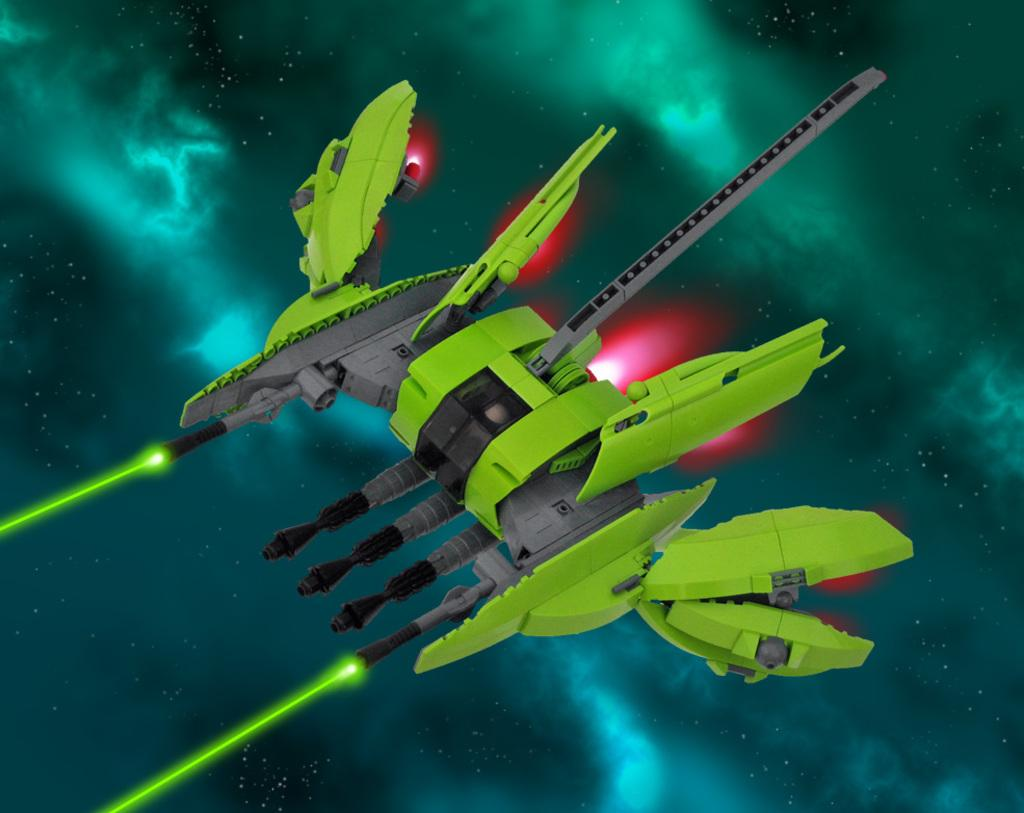What is the main subject in the sky in the image? There is a rocket in the sky in the image. What can be observed around the rocket? Colorful lights are visible around the rocket. Can you tell if the image has been altered or edited? Yes, the image appears to be edited. How many kittens are playing with the engine of the rocket in the image? There are no kittens or engines present in the image; it features a rocket with colorful lights in the sky. Can you tell me the color of the bee buzzing around the rocket in the image? There is no bee present in the image; it only features a rocket and colorful lights. 